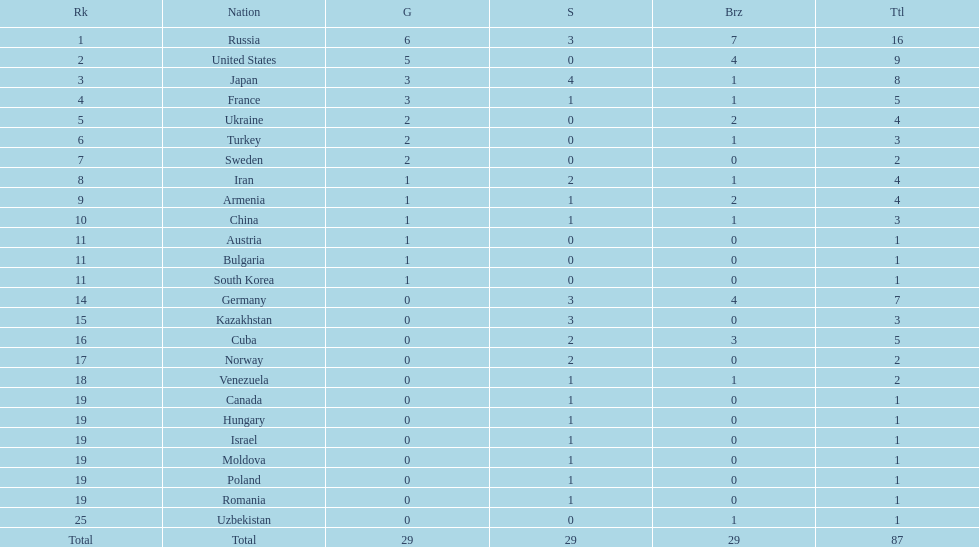Could you parse the entire table as a dict? {'header': ['Rk', 'Nation', 'G', 'S', 'Brz', 'Ttl'], 'rows': [['1', 'Russia', '6', '3', '7', '16'], ['2', 'United States', '5', '0', '4', '9'], ['3', 'Japan', '3', '4', '1', '8'], ['4', 'France', '3', '1', '1', '5'], ['5', 'Ukraine', '2', '0', '2', '4'], ['6', 'Turkey', '2', '0', '1', '3'], ['7', 'Sweden', '2', '0', '0', '2'], ['8', 'Iran', '1', '2', '1', '4'], ['9', 'Armenia', '1', '1', '2', '4'], ['10', 'China', '1', '1', '1', '3'], ['11', 'Austria', '1', '0', '0', '1'], ['11', 'Bulgaria', '1', '0', '0', '1'], ['11', 'South Korea', '1', '0', '0', '1'], ['14', 'Germany', '0', '3', '4', '7'], ['15', 'Kazakhstan', '0', '3', '0', '3'], ['16', 'Cuba', '0', '2', '3', '5'], ['17', 'Norway', '0', '2', '0', '2'], ['18', 'Venezuela', '0', '1', '1', '2'], ['19', 'Canada', '0', '1', '0', '1'], ['19', 'Hungary', '0', '1', '0', '1'], ['19', 'Israel', '0', '1', '0', '1'], ['19', 'Moldova', '0', '1', '0', '1'], ['19', 'Poland', '0', '1', '0', '1'], ['19', 'Romania', '0', '1', '0', '1'], ['25', 'Uzbekistan', '0', '0', '1', '1'], ['Total', 'Total', '29', '29', '29', '87']]} Which country won only one medal, a bronze medal? Uzbekistan. 